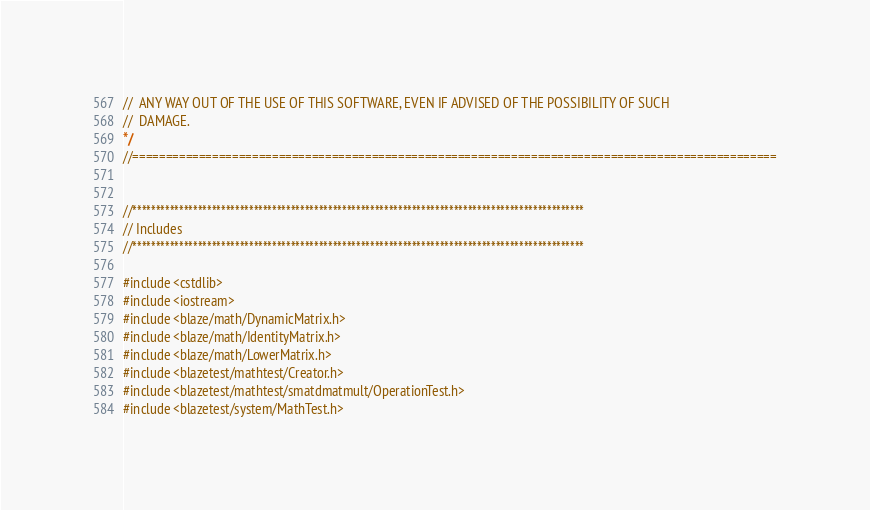Convert code to text. <code><loc_0><loc_0><loc_500><loc_500><_C++_>//  ANY WAY OUT OF THE USE OF THIS SOFTWARE, EVEN IF ADVISED OF THE POSSIBILITY OF SUCH
//  DAMAGE.
*/
//=================================================================================================


//*************************************************************************************************
// Includes
//*************************************************************************************************

#include <cstdlib>
#include <iostream>
#include <blaze/math/DynamicMatrix.h>
#include <blaze/math/IdentityMatrix.h>
#include <blaze/math/LowerMatrix.h>
#include <blazetest/mathtest/Creator.h>
#include <blazetest/mathtest/smatdmatmult/OperationTest.h>
#include <blazetest/system/MathTest.h>

</code> 